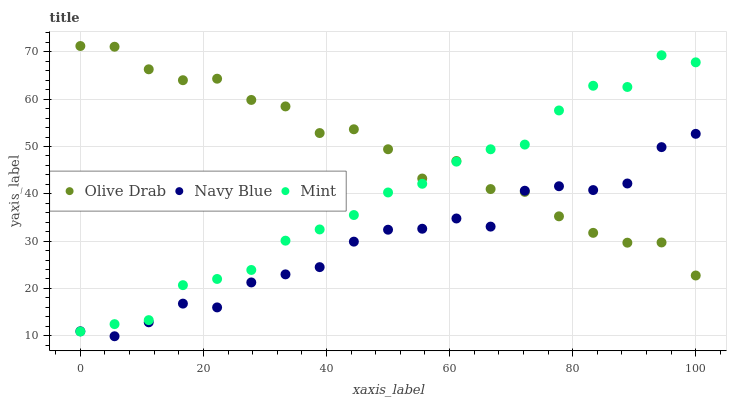Does Navy Blue have the minimum area under the curve?
Answer yes or no. Yes. Does Olive Drab have the maximum area under the curve?
Answer yes or no. Yes. Does Mint have the minimum area under the curve?
Answer yes or no. No. Does Mint have the maximum area under the curve?
Answer yes or no. No. Is Mint the smoothest?
Answer yes or no. Yes. Is Olive Drab the roughest?
Answer yes or no. Yes. Is Olive Drab the smoothest?
Answer yes or no. No. Is Mint the roughest?
Answer yes or no. No. Does Navy Blue have the lowest value?
Answer yes or no. Yes. Does Mint have the lowest value?
Answer yes or no. No. Does Olive Drab have the highest value?
Answer yes or no. Yes. Does Mint have the highest value?
Answer yes or no. No. Does Navy Blue intersect Olive Drab?
Answer yes or no. Yes. Is Navy Blue less than Olive Drab?
Answer yes or no. No. Is Navy Blue greater than Olive Drab?
Answer yes or no. No. 